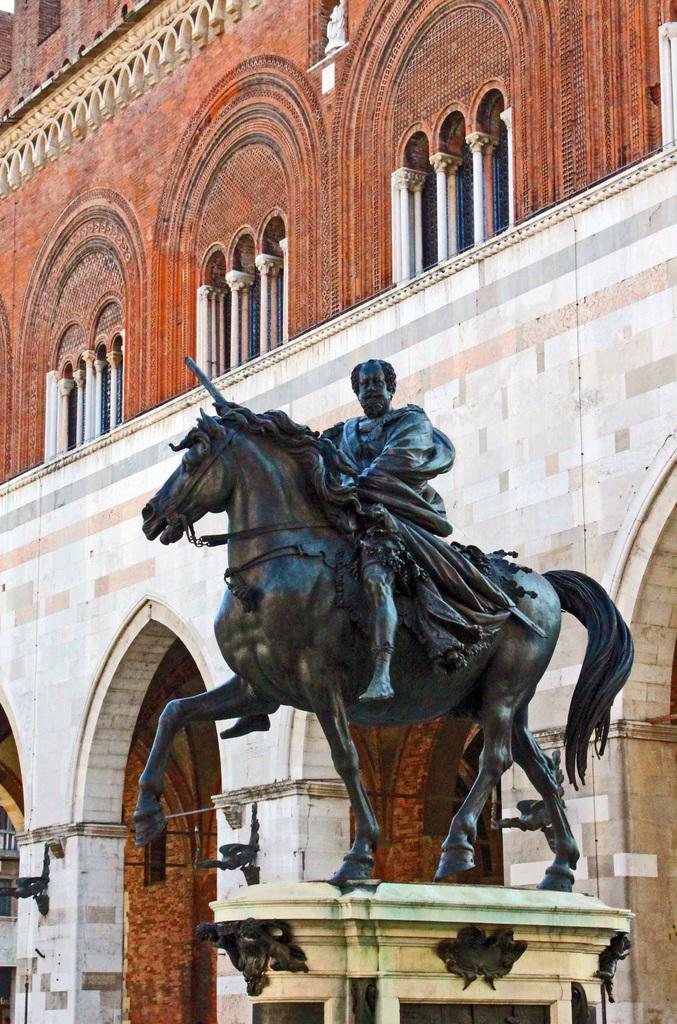What is the main subject in the center of the image? There is a sculpture in the center of the image. What can be seen in the background of the image? There is a building in the background of the image. What type of bomb is depicted in the sculpture? There is no bomb depicted in the sculpture; it is a sculpture and not a representation of a bomb. 